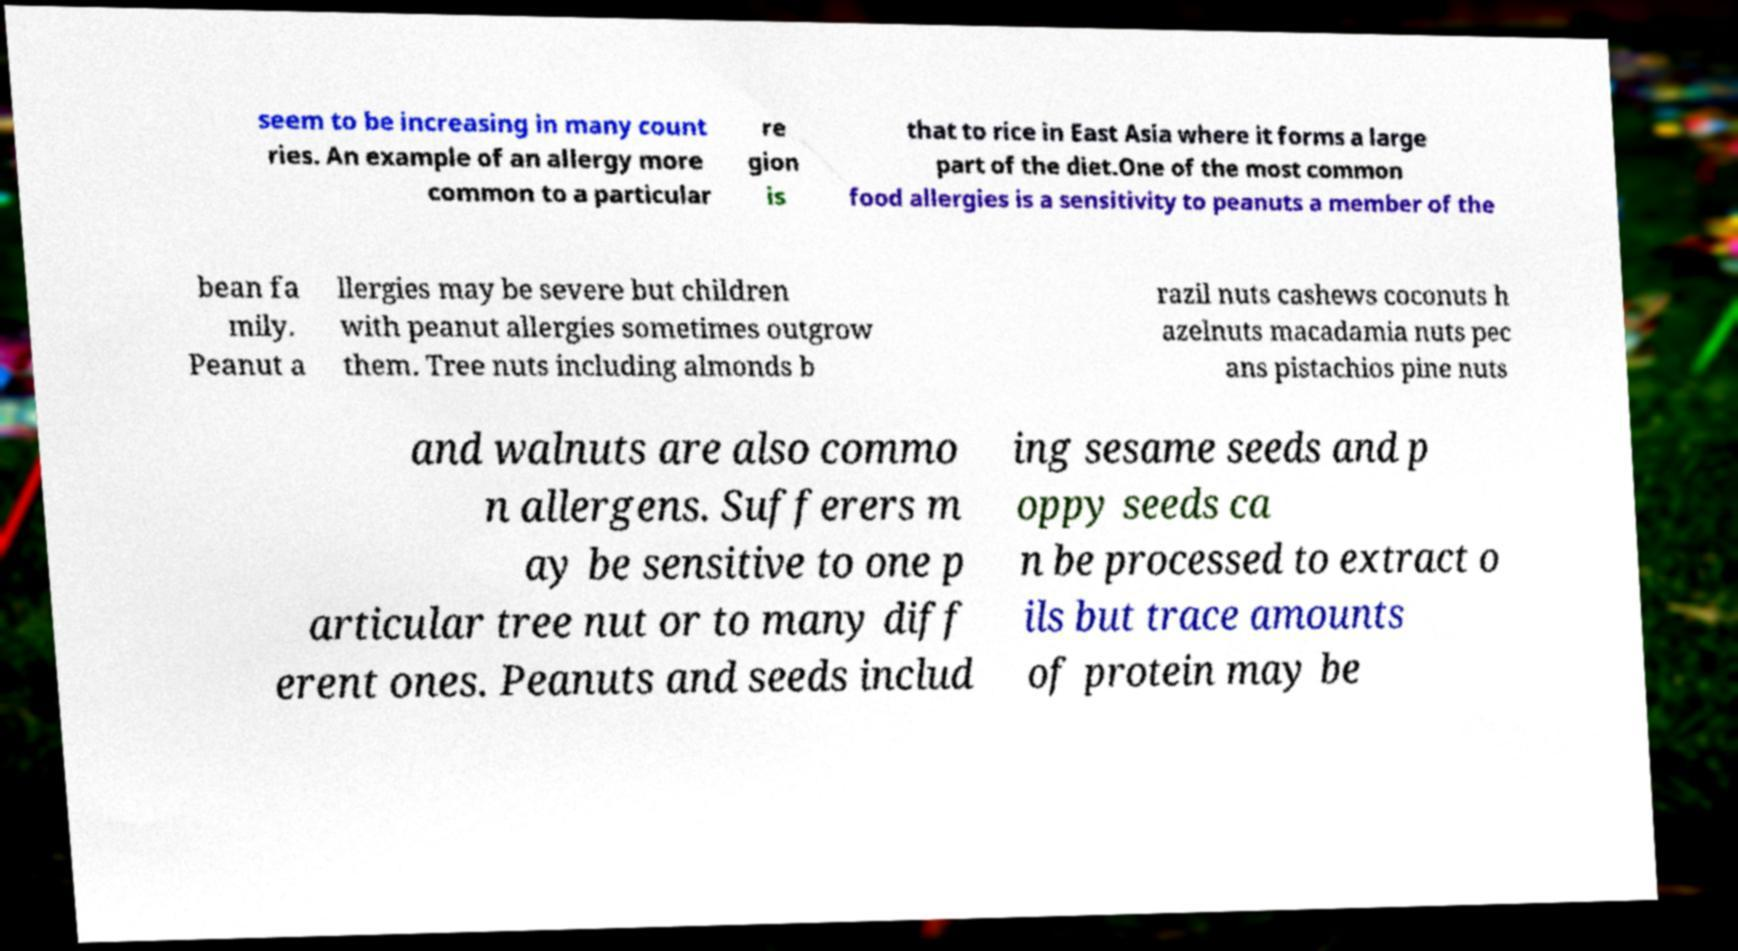There's text embedded in this image that I need extracted. Can you transcribe it verbatim? seem to be increasing in many count ries. An example of an allergy more common to a particular re gion is that to rice in East Asia where it forms a large part of the diet.One of the most common food allergies is a sensitivity to peanuts a member of the bean fa mily. Peanut a llergies may be severe but children with peanut allergies sometimes outgrow them. Tree nuts including almonds b razil nuts cashews coconuts h azelnuts macadamia nuts pec ans pistachios pine nuts and walnuts are also commo n allergens. Sufferers m ay be sensitive to one p articular tree nut or to many diff erent ones. Peanuts and seeds includ ing sesame seeds and p oppy seeds ca n be processed to extract o ils but trace amounts of protein may be 